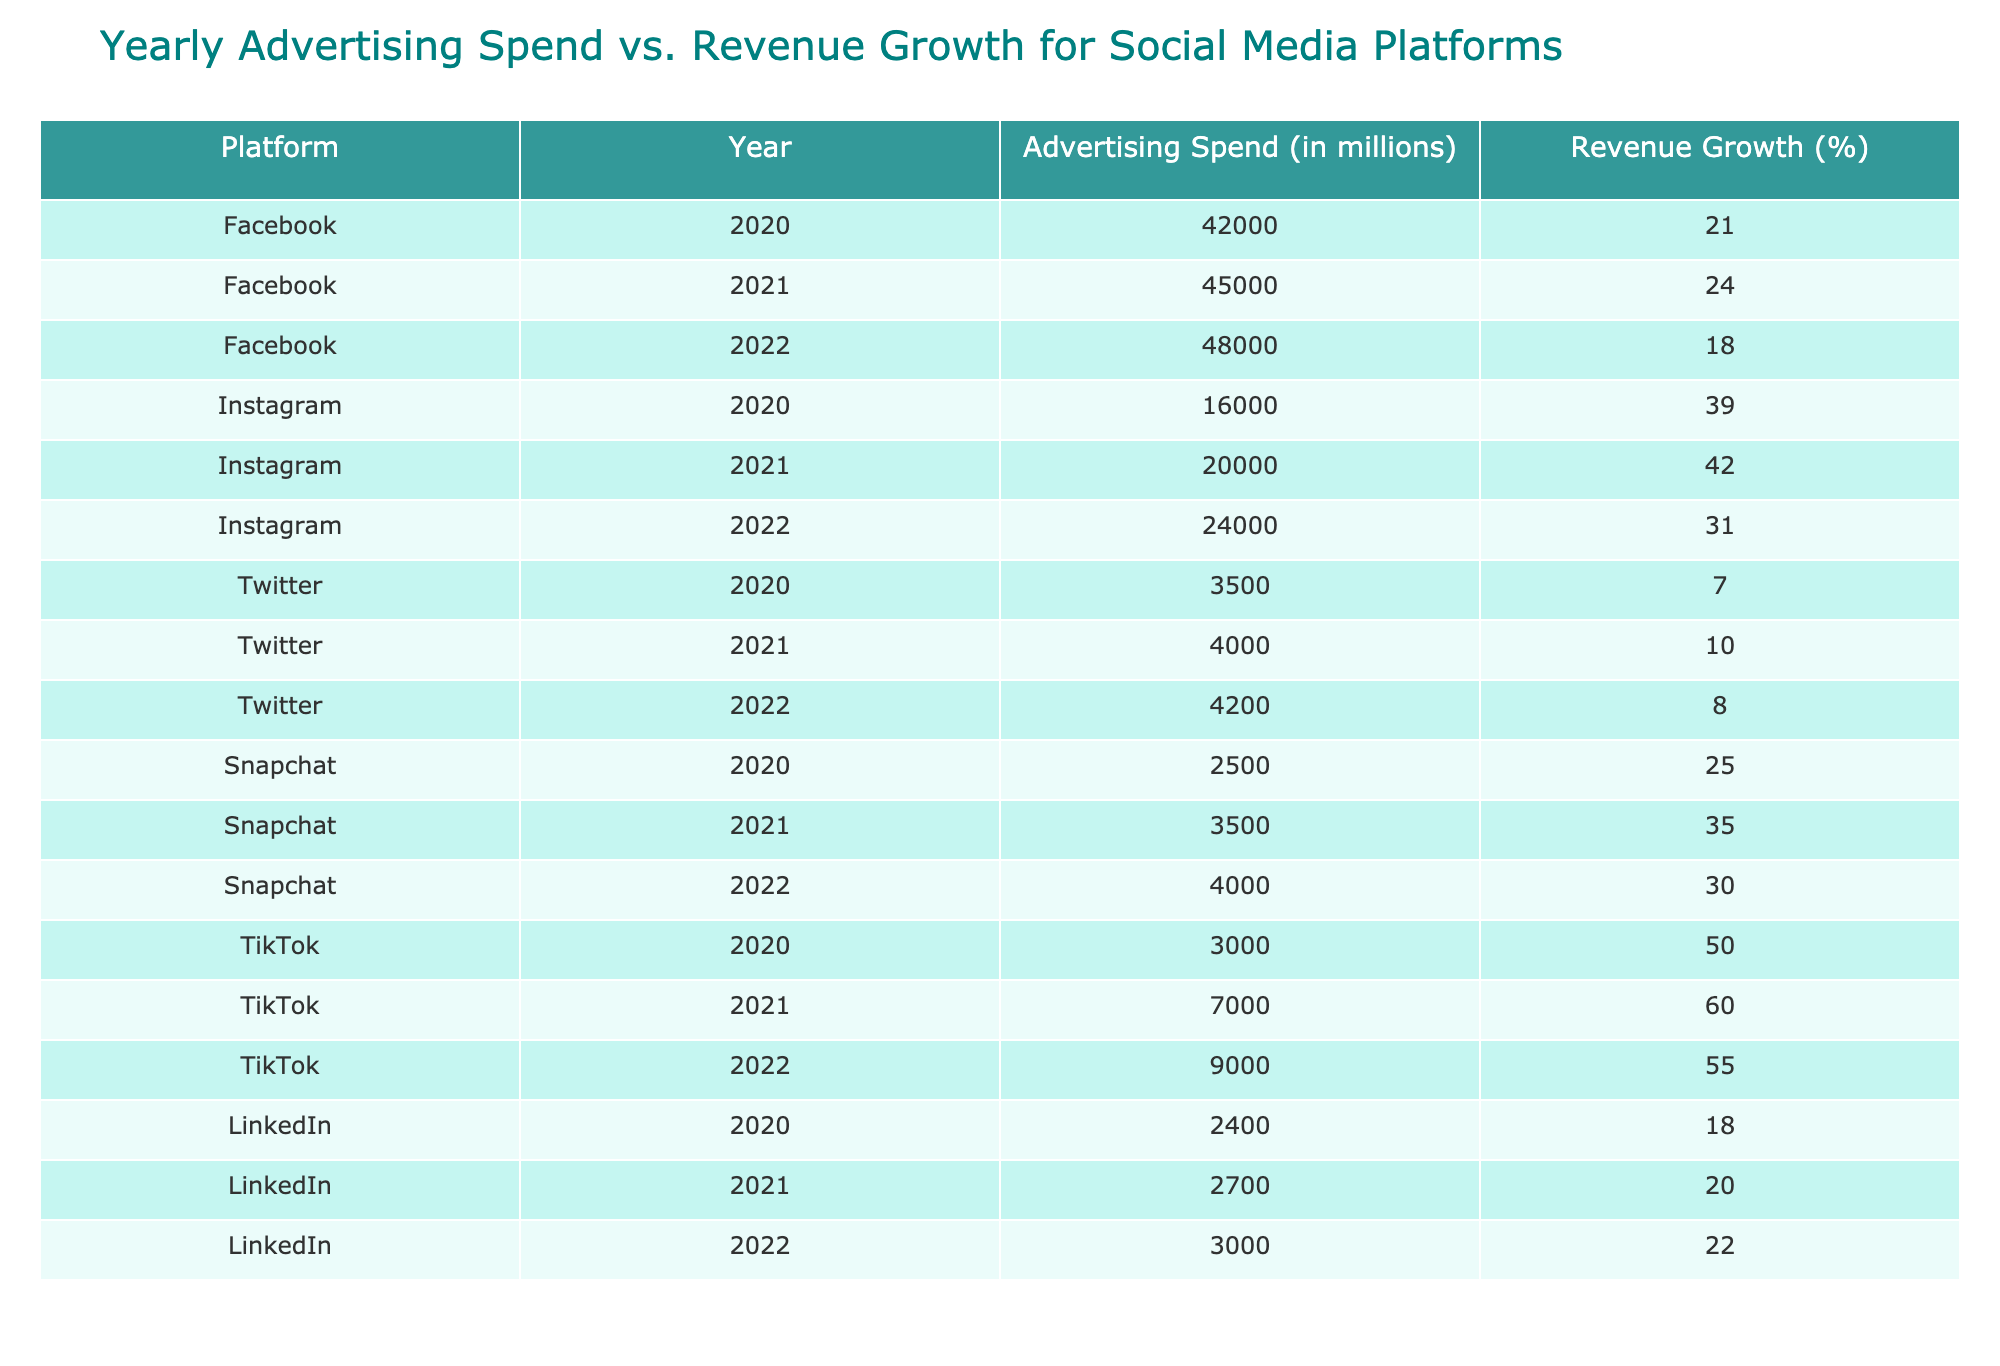What was the advertising spend for TikTok in 2021? According to the table, the advertising spend for TikTok in 2021 is explicitly listed as 7000 million.
Answer: 7000 million What is the revenue growth percentage for Instagram in 2022? From the table, the revenue growth percentage for Instagram in 2022 is directly provided as 31%.
Answer: 31% Which social media platform had the highest advertising spend in 2022? Upon reviewing the advertising spend for 2022, Facebook has the highest spend at 48000 million, compared to other platforms.
Answer: Facebook What is the average revenue growth percentage for LinkedIn over the three years? To find the average, we sum the revenue growth percentages for LinkedIn (18 + 20 + 22 = 60) and divide by the number of years (3), resulting in an average of 20%.
Answer: 20% Did Snapchat show an increase in both advertising spend and revenue growth from 2021 to 2022? For Snapchat, the advertising spend increased from 3500 million in 2021 to 4000 million in 2022, while revenue growth decreased from 35% in 2021 to 30% in 2022. Since revenue growth decreased, the answer is no.
Answer: No Which platform had the largest increase in advertising spend from 2020 to 2021? Looking at the data, Instagram increased its advertising spend from 16000 million in 2020 to 20000 million in 2021, a difference of 4000 million, which is the largest increase among the platforms in that year.
Answer: Instagram Is it true that Facebook had a revenue growth percentage higher than 20% in all three years? Checking Facebook's revenue growth percentages: 21% (2020), 24% (2021), and 18% (2022). Since the growth in 2022 was 18%, the claim is false.
Answer: No What was the combined advertising spend for Twitter across all three years? By summing the advertising spends for Twitter: 3500 million (2020) + 4000 million (2021) + 4200 million (2022) gives a total of 11700 million.
Answer: 11700 million Which platform had the highest revenue growth in 2021? Looking across the table, TikTok had the highest revenue growth in 2021 at 60%, exceeding all other platforms' growth percentages for that year.
Answer: TikTok 